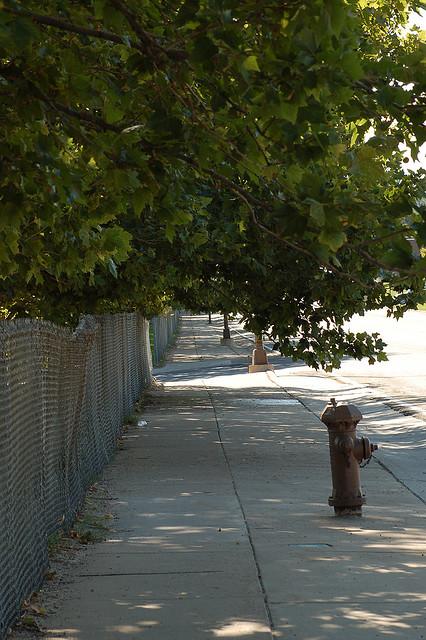Are there leaves on the trees?
Answer the question using a single word or phrase. Yes Are there flowers in the photo? No Are there leaves on the ground? Yes How many fire hydrants are pictured? 1 